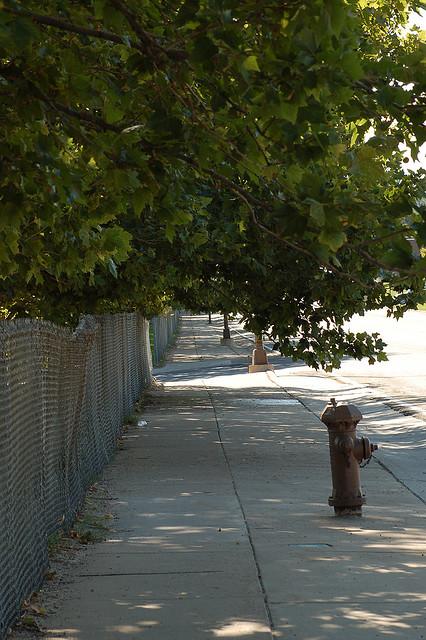Are there leaves on the trees?
Answer the question using a single word or phrase. Yes Are there flowers in the photo? No Are there leaves on the ground? Yes How many fire hydrants are pictured? 1 